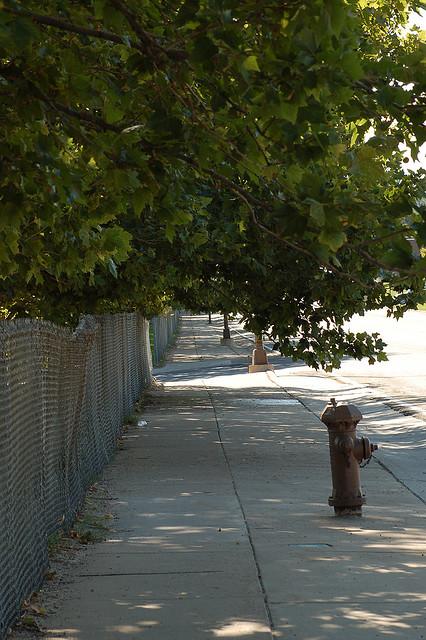Are there leaves on the trees?
Answer the question using a single word or phrase. Yes Are there flowers in the photo? No Are there leaves on the ground? Yes How many fire hydrants are pictured? 1 